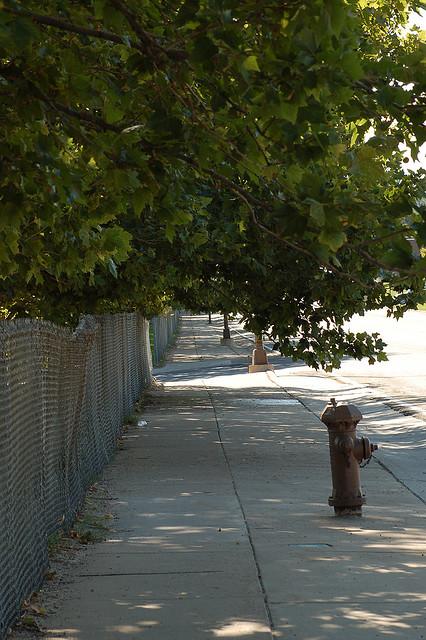Are there leaves on the trees?
Answer the question using a single word or phrase. Yes Are there flowers in the photo? No Are there leaves on the ground? Yes How many fire hydrants are pictured? 1 